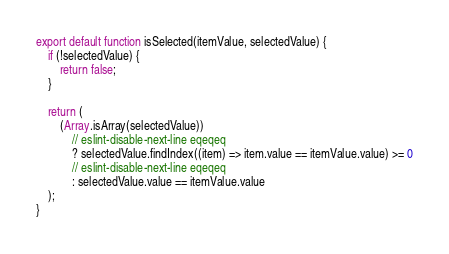Convert code to text. <code><loc_0><loc_0><loc_500><loc_500><_JavaScript_>export default function isSelected(itemValue, selectedValue) {
    if (!selectedValue) {
        return false;
    }

    return (
        (Array.isArray(selectedValue))
            // eslint-disable-next-line eqeqeq
            ? selectedValue.findIndex((item) => item.value == itemValue.value) >= 0
            // eslint-disable-next-line eqeqeq
            : selectedValue.value == itemValue.value
    );
}
</code> 